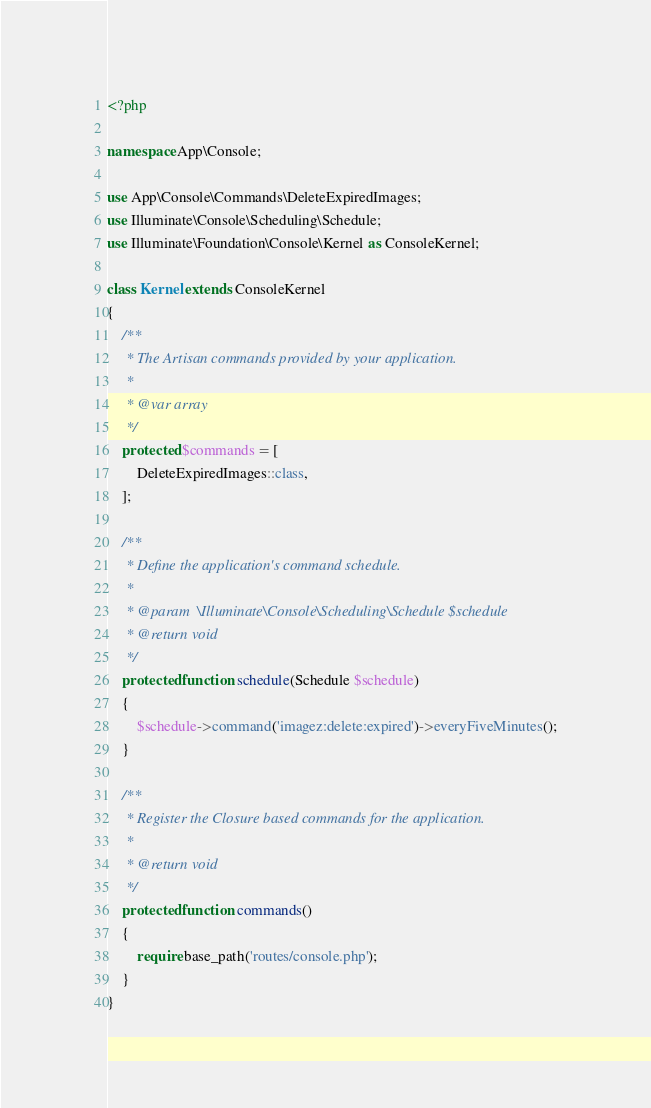<code> <loc_0><loc_0><loc_500><loc_500><_PHP_><?php

namespace App\Console;

use App\Console\Commands\DeleteExpiredImages;
use Illuminate\Console\Scheduling\Schedule;
use Illuminate\Foundation\Console\Kernel as ConsoleKernel;

class Kernel extends ConsoleKernel
{
    /**
     * The Artisan commands provided by your application.
     *
     * @var array
     */
    protected $commands = [
        DeleteExpiredImages::class,
    ];

    /**
     * Define the application's command schedule.
     *
     * @param  \Illuminate\Console\Scheduling\Schedule $schedule
     * @return void
     */
    protected function schedule(Schedule $schedule)
    {
        $schedule->command('imagez:delete:expired')->everyFiveMinutes();
    }

    /**
     * Register the Closure based commands for the application.
     *
     * @return void
     */
    protected function commands()
    {
        require base_path('routes/console.php');
    }
}
</code> 